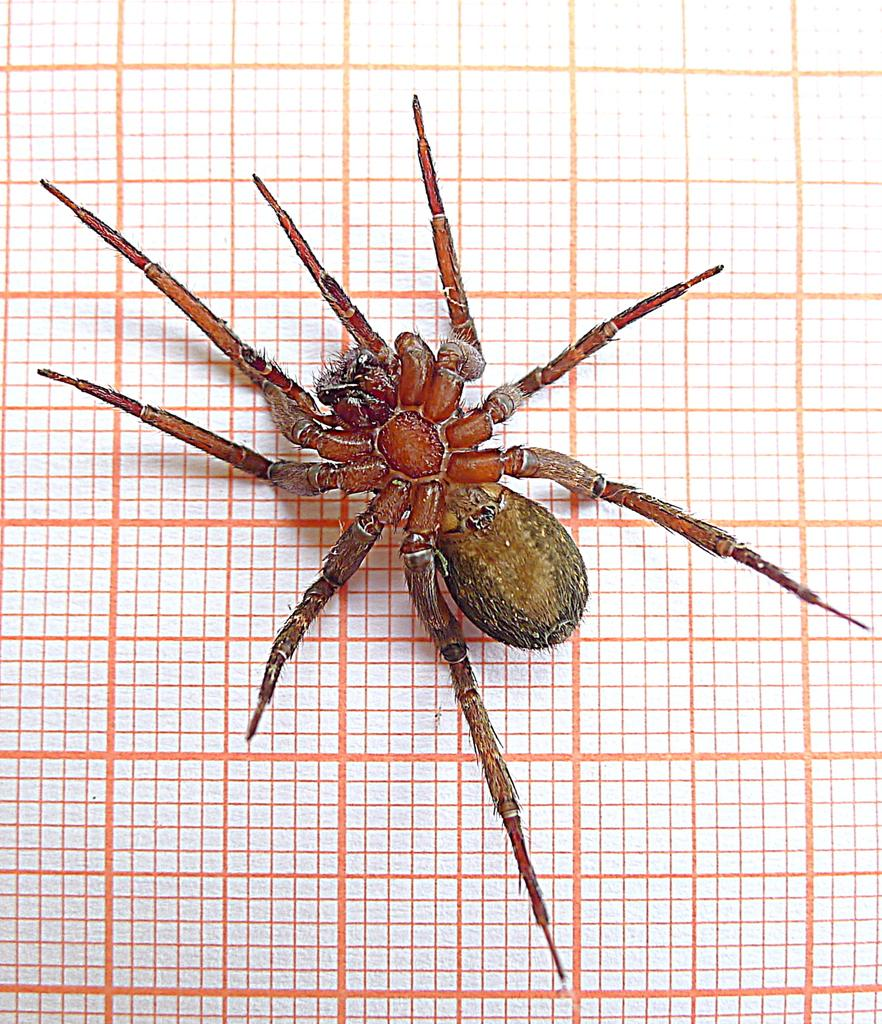What is the main subject of the image? There is a spider in the image. Where is the spider located? The spider is on a fence. Can you tell if the image was taken during the day or night? The image was likely taken during the day. What type of crook is the spider trying to catch in the image? There is no crook present in the image, as it features a spider on a fence. How does the wren feel about the spider in the image? There is no wren present in the image, so it is impossible to determine how it might feel about the spider. 